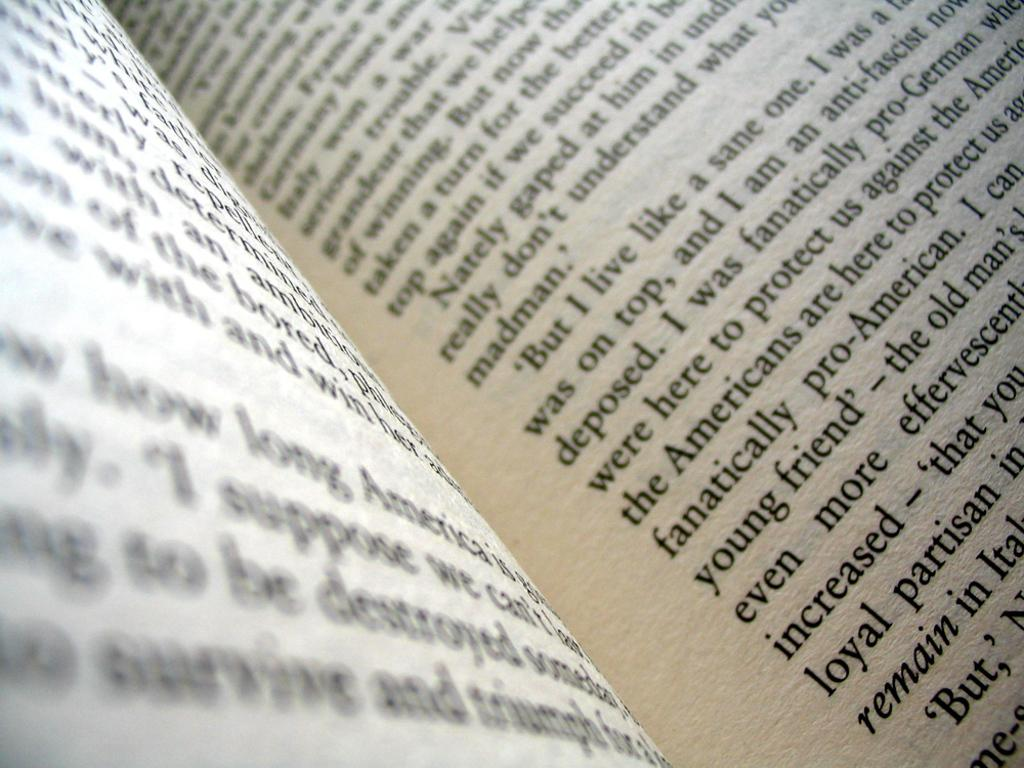<image>
Relay a brief, clear account of the picture shown. Chapter book that expresses about being Pro German against the Americans. 